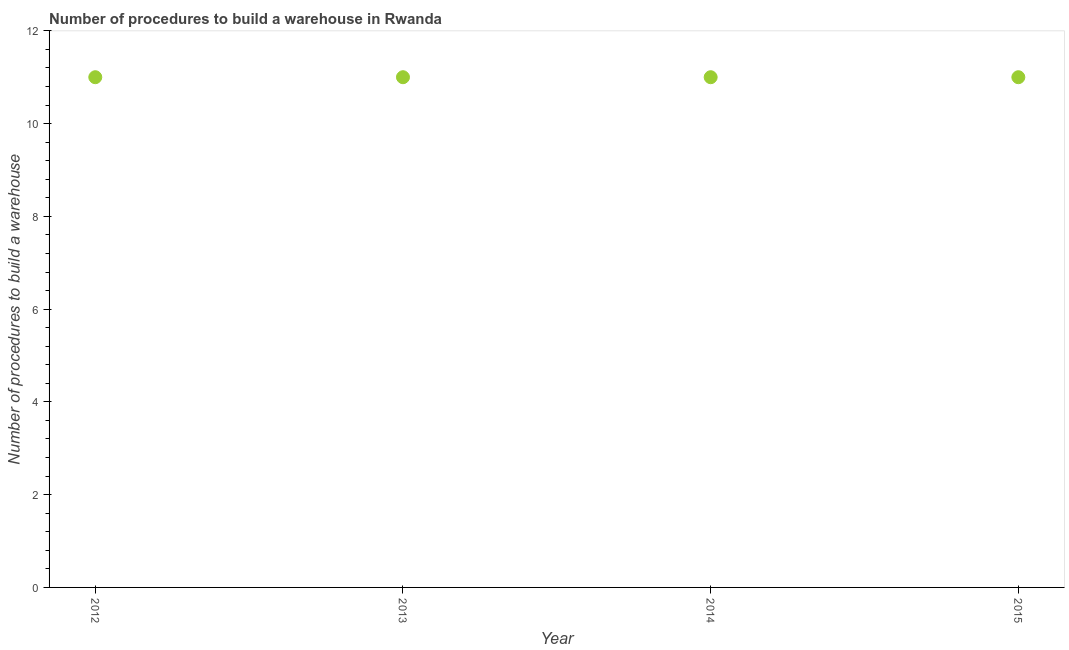What is the number of procedures to build a warehouse in 2013?
Your answer should be very brief. 11. Across all years, what is the maximum number of procedures to build a warehouse?
Your answer should be very brief. 11. Across all years, what is the minimum number of procedures to build a warehouse?
Provide a short and direct response. 11. In which year was the number of procedures to build a warehouse minimum?
Give a very brief answer. 2012. What is the sum of the number of procedures to build a warehouse?
Offer a very short reply. 44. What is the difference between the number of procedures to build a warehouse in 2012 and 2013?
Offer a terse response. 0. What is the average number of procedures to build a warehouse per year?
Your answer should be very brief. 11. What is the median number of procedures to build a warehouse?
Make the answer very short. 11. In how many years, is the number of procedures to build a warehouse greater than 4 ?
Provide a short and direct response. 4. Do a majority of the years between 2012 and 2013 (inclusive) have number of procedures to build a warehouse greater than 9.2 ?
Provide a succinct answer. Yes. What is the ratio of the number of procedures to build a warehouse in 2014 to that in 2015?
Your answer should be very brief. 1. Is the difference between the number of procedures to build a warehouse in 2012 and 2015 greater than the difference between any two years?
Offer a very short reply. Yes. What is the difference between the highest and the second highest number of procedures to build a warehouse?
Give a very brief answer. 0. In how many years, is the number of procedures to build a warehouse greater than the average number of procedures to build a warehouse taken over all years?
Make the answer very short. 0. How many dotlines are there?
Ensure brevity in your answer.  1. How many years are there in the graph?
Keep it short and to the point. 4. What is the difference between two consecutive major ticks on the Y-axis?
Give a very brief answer. 2. Are the values on the major ticks of Y-axis written in scientific E-notation?
Make the answer very short. No. Does the graph contain grids?
Your response must be concise. No. What is the title of the graph?
Provide a short and direct response. Number of procedures to build a warehouse in Rwanda. What is the label or title of the Y-axis?
Provide a succinct answer. Number of procedures to build a warehouse. What is the Number of procedures to build a warehouse in 2013?
Your answer should be compact. 11. What is the difference between the Number of procedures to build a warehouse in 2012 and 2014?
Make the answer very short. 0. What is the difference between the Number of procedures to build a warehouse in 2012 and 2015?
Offer a terse response. 0. What is the difference between the Number of procedures to build a warehouse in 2013 and 2015?
Give a very brief answer. 0. What is the difference between the Number of procedures to build a warehouse in 2014 and 2015?
Make the answer very short. 0. What is the ratio of the Number of procedures to build a warehouse in 2012 to that in 2013?
Your answer should be compact. 1. What is the ratio of the Number of procedures to build a warehouse in 2013 to that in 2015?
Your answer should be very brief. 1. What is the ratio of the Number of procedures to build a warehouse in 2014 to that in 2015?
Provide a short and direct response. 1. 